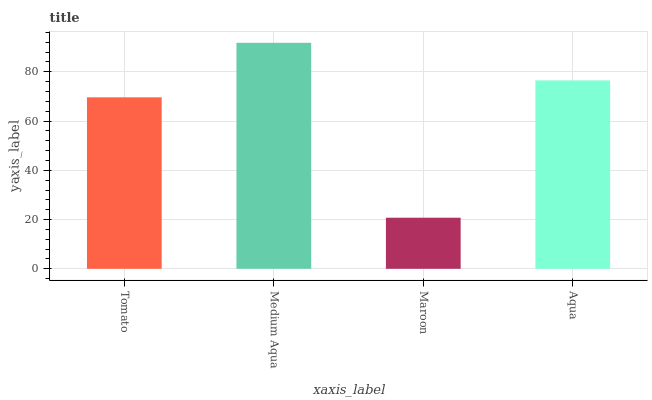Is Maroon the minimum?
Answer yes or no. Yes. Is Medium Aqua the maximum?
Answer yes or no. Yes. Is Medium Aqua the minimum?
Answer yes or no. No. Is Maroon the maximum?
Answer yes or no. No. Is Medium Aqua greater than Maroon?
Answer yes or no. Yes. Is Maroon less than Medium Aqua?
Answer yes or no. Yes. Is Maroon greater than Medium Aqua?
Answer yes or no. No. Is Medium Aqua less than Maroon?
Answer yes or no. No. Is Aqua the high median?
Answer yes or no. Yes. Is Tomato the low median?
Answer yes or no. Yes. Is Medium Aqua the high median?
Answer yes or no. No. Is Aqua the low median?
Answer yes or no. No. 